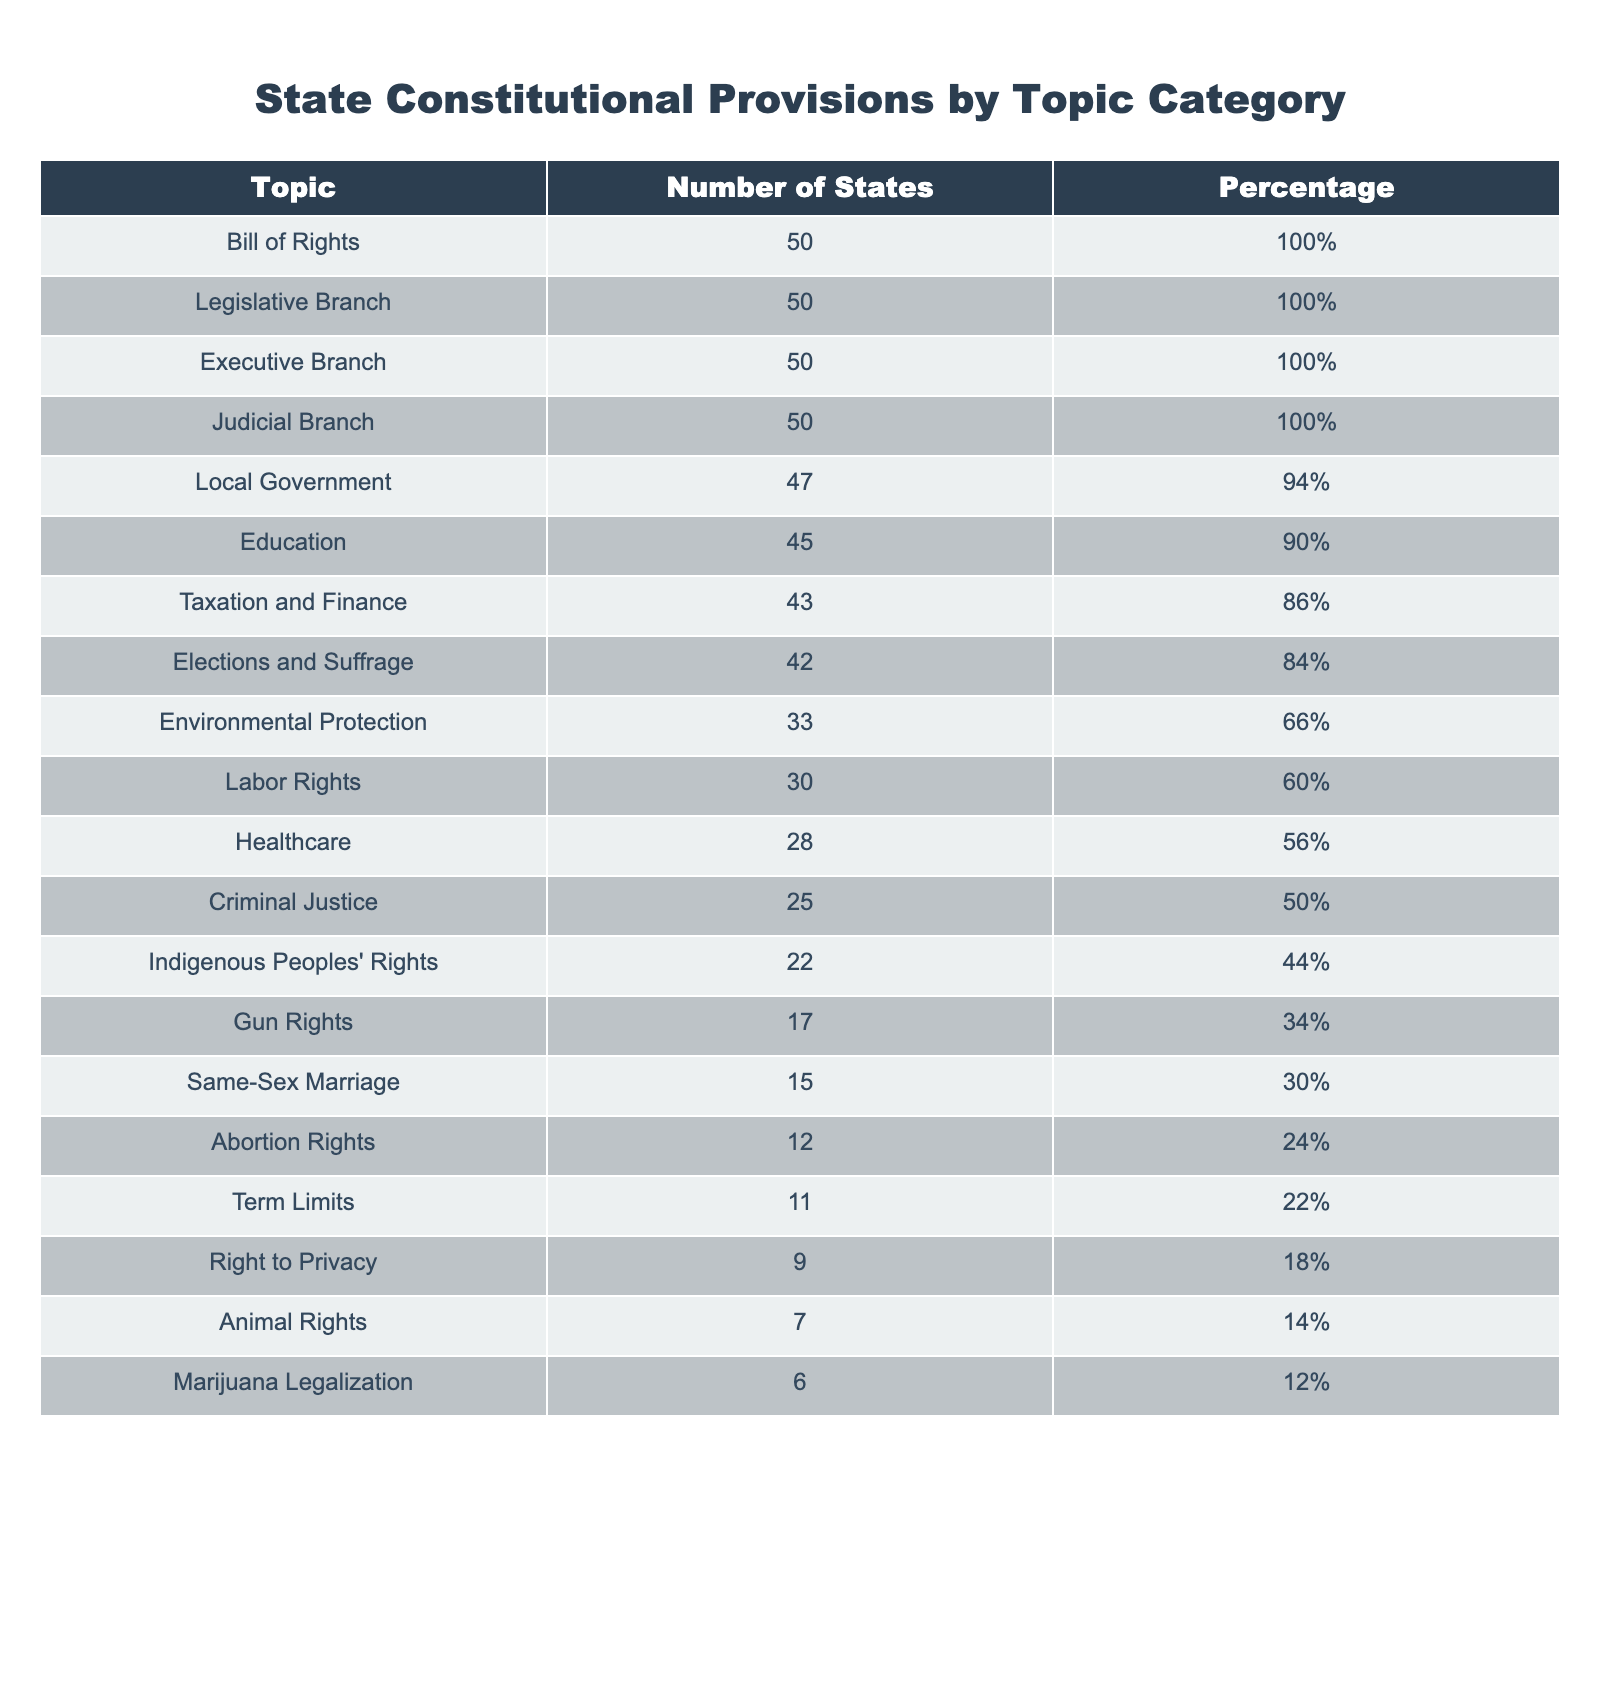What is the total number of states that have provisions for Local Government? The table shows that 47 states consist of provisions for Local Government. This value is directly stated in the "Number of States" column corresponding to the "Local Government" topic.
Answer: 47 Which topic has the least number of states with provisions? According to the table, the topic with the least number of states is "Marijuana Legalization," which has provisions in 6 states. This is found by comparing all values in the "Number of States" column.
Answer: 6 Is there a greater number of states with provisions for Education or Healthcare? The number of states with Education provisions is 45, and for Healthcare it is 28. Since 45 is greater than 28, there are more states with Education provisions.
Answer: Yes, Education has more states What percentage of states have provisions for Criminal Justice? The table states that 25 states have provisions for Criminal Justice. To find the percentage, we take (25/50)*100 = 50%. This calculation confirms that 50% of states have these provisions.
Answer: 50% How many more states have provisions for Taxation and Finance than for Same-Sex Marriage? The number of states with Taxation and Finance is 43, and with Same-Sex Marriage it is 15. Calculating the difference, 43 - 15 = 28. Therefore, there are 28 more states with provisions for Taxation and Finance.
Answer: 28 What is the average number of states having provisions for Gun Rights, Same-Sex Marriage, and Abortion Rights? The number of states for Gun Rights is 17, Same-Sex Marriage is 15, and Abortion Rights is 12. The average is calculated as (17 + 15 + 12) / 3 = 44 / 3 = 14.67. This gives the average number of states across these three categories.
Answer: 14.67 Which two topics have provisions in the same number of states? Upon reviewing the table, we see that the topics of Term Limits (11 states) and Right to Privacy (9 states) do not match any other topics, indicating there are no two topics with the same number.
Answer: None, all are unique How many states are there with provisions for both Environmental Protection and Labor Rights? The table does not show explicit overlap for individual states with these provisions, but it shows 33 for Environmental Protection and 30 for Labor Rights. Thus, they are counted separately, though some might overlap.
Answer: Cannot determine from the table Which provision category represents at least 50% of the states? To find which ones are above 50%, we look at the percentages: Bill of Rights, Legislative Branch, Executive Branch, Judicial Branch, Local Government, Education, Taxation and Finance, Elections and Suffrage, and Criminal Justice all meet this criterion. Specifically, they each are 86% or higher, confirming their majority status.
Answer: 9 categories 